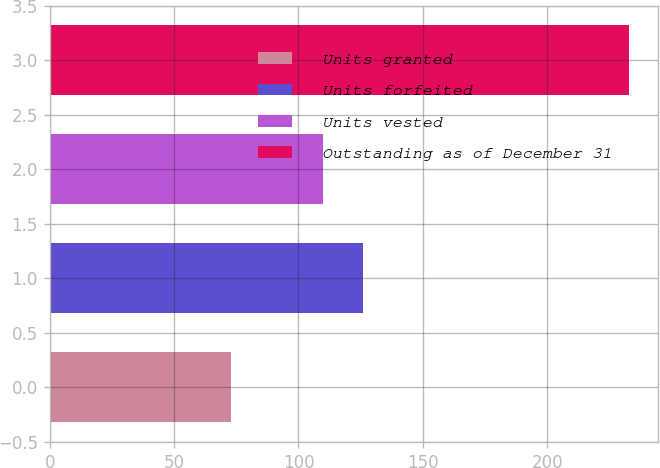Convert chart. <chart><loc_0><loc_0><loc_500><loc_500><bar_chart><fcel>Units granted<fcel>Units forfeited<fcel>Units vested<fcel>Outstanding as of December 31<nl><fcel>73<fcel>126<fcel>110<fcel>233<nl></chart> 